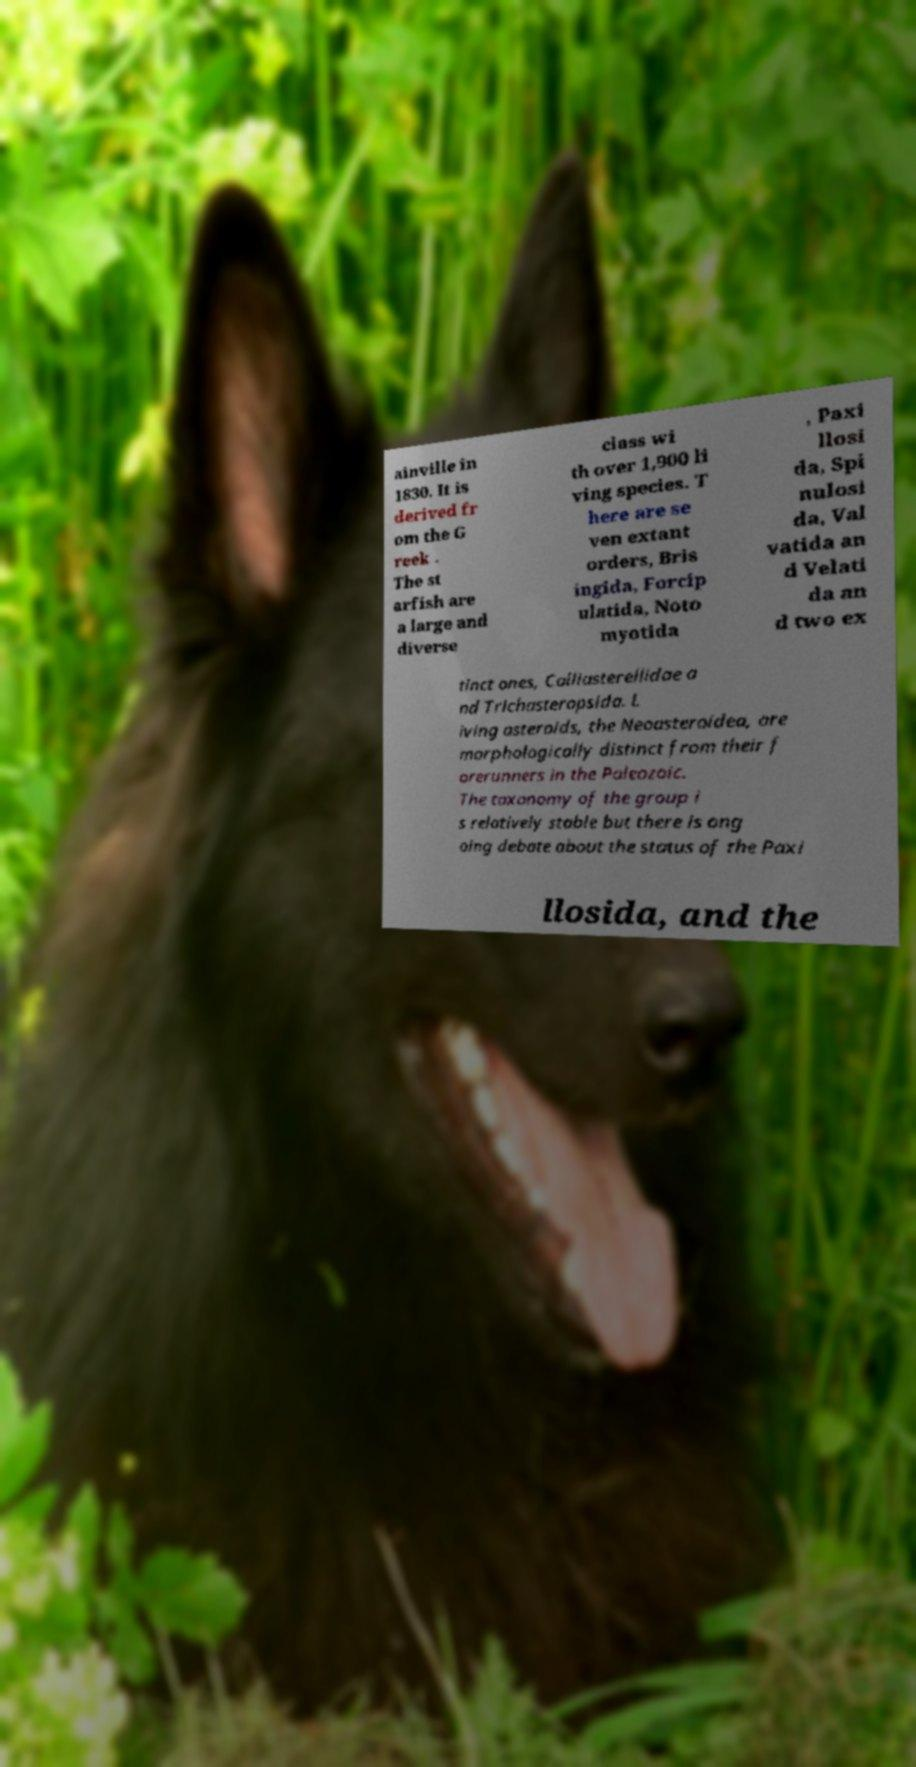Could you assist in decoding the text presented in this image and type it out clearly? ainville in 1830. It is derived fr om the G reek . The st arfish are a large and diverse class wi th over 1,900 li ving species. T here are se ven extant orders, Bris ingida, Forcip ulatida, Noto myotida , Paxi llosi da, Spi nulosi da, Val vatida an d Velati da an d two ex tinct ones, Calliasterellidae a nd Trichasteropsida. L iving asteroids, the Neoasteroidea, are morphologically distinct from their f orerunners in the Paleozoic. The taxonomy of the group i s relatively stable but there is ong oing debate about the status of the Paxi llosida, and the 